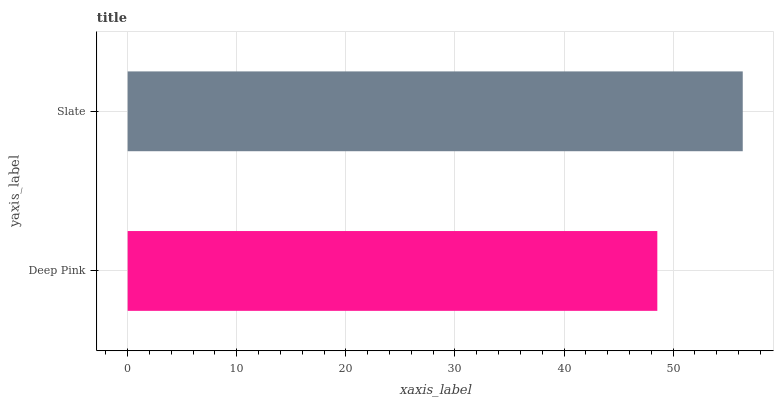Is Deep Pink the minimum?
Answer yes or no. Yes. Is Slate the maximum?
Answer yes or no. Yes. Is Slate the minimum?
Answer yes or no. No. Is Slate greater than Deep Pink?
Answer yes or no. Yes. Is Deep Pink less than Slate?
Answer yes or no. Yes. Is Deep Pink greater than Slate?
Answer yes or no. No. Is Slate less than Deep Pink?
Answer yes or no. No. Is Slate the high median?
Answer yes or no. Yes. Is Deep Pink the low median?
Answer yes or no. Yes. Is Deep Pink the high median?
Answer yes or no. No. Is Slate the low median?
Answer yes or no. No. 